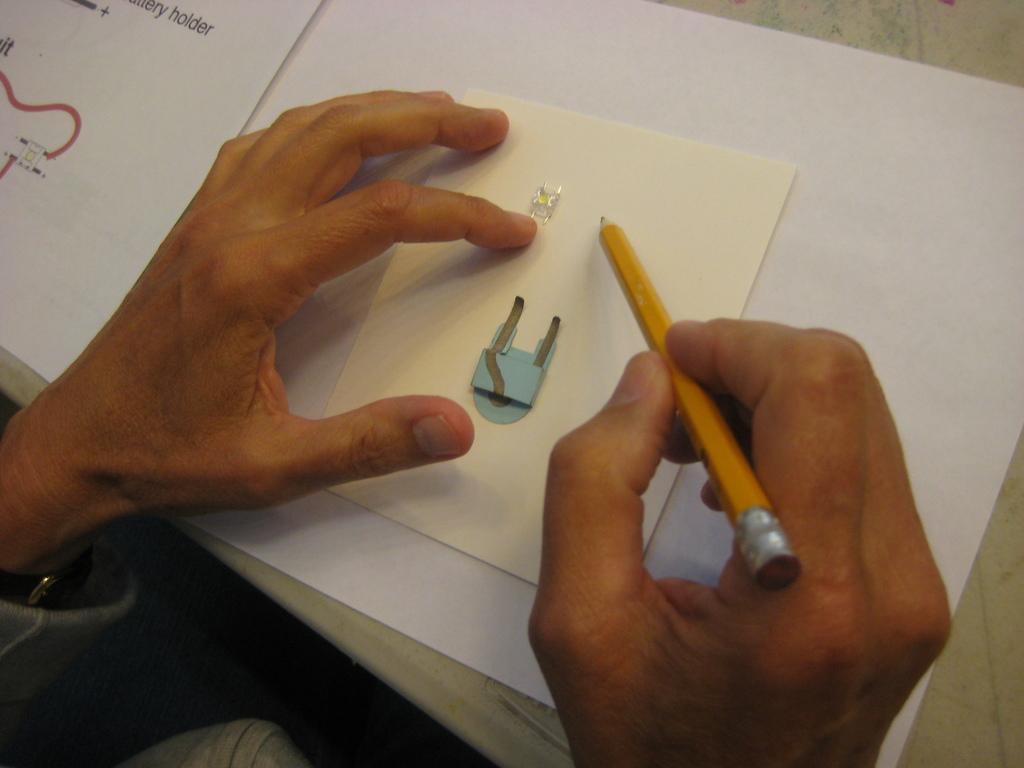Could you give a brief overview of what you see in this image? In this image we can see a person's hands. A person is holding a pencil in his hand. There is an object in the image. 